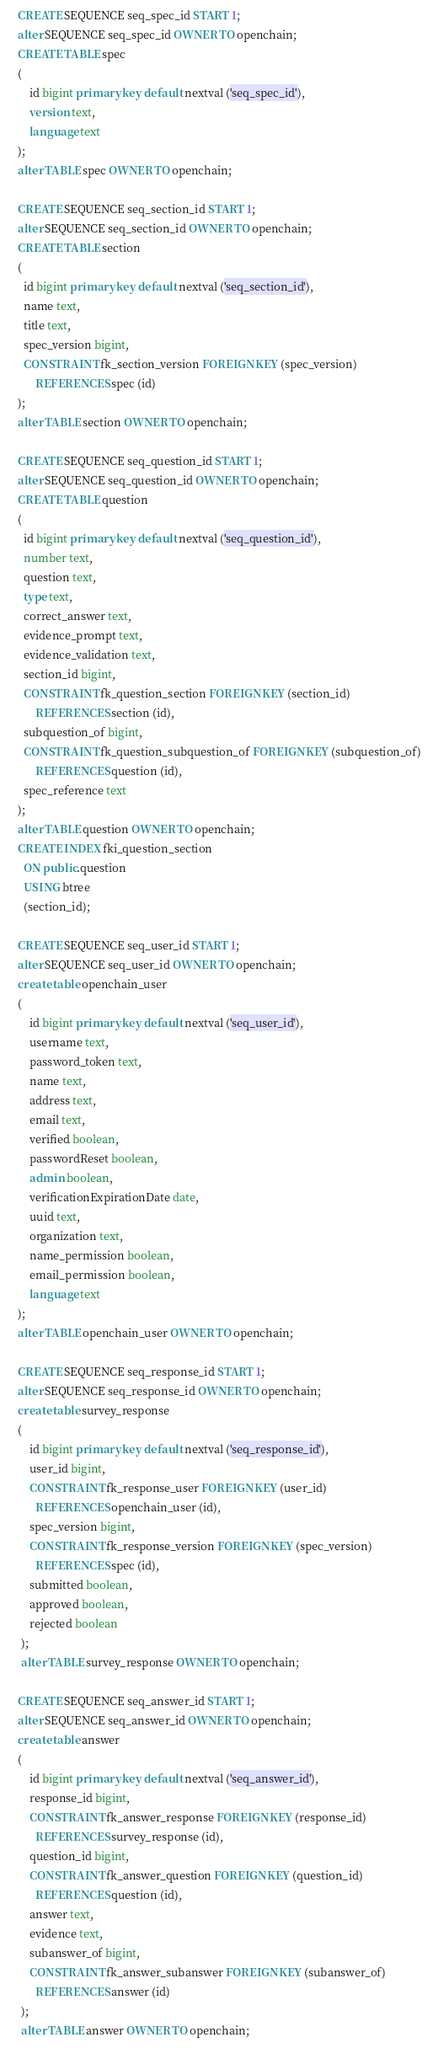Convert code to text. <code><loc_0><loc_0><loc_500><loc_500><_SQL_>	CREATE SEQUENCE seq_spec_id START 1;
	alter SEQUENCE seq_spec_id OWNER TO openchain; 
	CREATE TABLE spec
	(
	    id bigint primary key default nextval ('seq_spec_id'),
	    version text,
	    language text
	);
	alter TABLE spec OWNER TO openchain;
	
	CREATE SEQUENCE seq_section_id START 1;
	alter SEQUENCE seq_section_id OWNER TO openchain; 
	CREATE TABLE section
	(
	  id bigint primary key default nextval ('seq_section_id'),
	  name text,
	  title text,
	  spec_version bigint,
	  CONSTRAINT fk_section_version FOREIGN KEY (spec_version)
	      REFERENCES spec (id)
	);
	alter TABLE section OWNER TO openchain;
	
	CREATE SEQUENCE seq_question_id START 1;
	alter SEQUENCE seq_question_id OWNER TO openchain;
	CREATE TABLE question
	(
	  id bigint primary key default nextval ('seq_question_id'),
	  number text,
	  question text,
	  type text,
	  correct_answer text,
	  evidence_prompt text,
	  evidence_validation text,
	  section_id bigint,
	  CONSTRAINT fk_question_section FOREIGN KEY (section_id)
	      REFERENCES section (id),
	  subquestion_of bigint,
	  CONSTRAINT fk_question_subquestion_of FOREIGN KEY (subquestion_of)
	      REFERENCES question (id),
	  spec_reference text
	);
	alter TABLE question OWNER TO openchain;
	CREATE INDEX fki_question_section
	  ON public.question
	  USING btree
	  (section_id);
	  
	CREATE SEQUENCE seq_user_id START 1;
	alter SEQUENCE seq_user_id OWNER TO openchain;
	create table openchain_user
	(
	    id bigint primary key default nextval ('seq_user_id'),
	    username text,
	    password_token text,
	    name text,
	    address text,
	    email text,
	    verified boolean,
	    passwordReset boolean,
	    admin boolean,
	    verificationExpirationDate date,
	    uuid text,
	    organization text,
	    name_permission boolean,
	    email_permission boolean,
	    language text
	);
	alter TABLE openchain_user OWNER TO openchain;
	
	CREATE SEQUENCE seq_response_id START 1;
	alter SEQUENCE seq_response_id OWNER TO openchain;
	create table survey_response
	(
	    id bigint primary key default nextval ('seq_response_id'),
	    user_id bigint,
	    CONSTRAINT fk_response_user FOREIGN KEY (user_id)
	      REFERENCES openchain_user (id),
	    spec_version bigint,
	    CONSTRAINT fk_response_version FOREIGN KEY (spec_version)
	      REFERENCES spec (id),
	    submitted boolean,
	    approved boolean,
	    rejected boolean
	 );
	 alter TABLE survey_response OWNER TO openchain;
	    
	CREATE SEQUENCE seq_answer_id START 1;
	alter SEQUENCE seq_answer_id OWNER TO openchain;
	create table answer
	(
	    id bigint primary key default nextval ('seq_answer_id'),
	    response_id bigint,
	    CONSTRAINT fk_answer_response FOREIGN KEY (response_id)
	      REFERENCES survey_response (id),
	    question_id bigint,
	    CONSTRAINT fk_answer_question FOREIGN KEY (question_id)
	      REFERENCES question (id),
	    answer text,
	    evidence text,
	    subanswer_of bigint,
	    CONSTRAINT fk_answer_subanswer FOREIGN KEY (subanswer_of)
	      REFERENCES answer (id)
	 );
	 alter TABLE answer OWNER TO openchain; </code> 